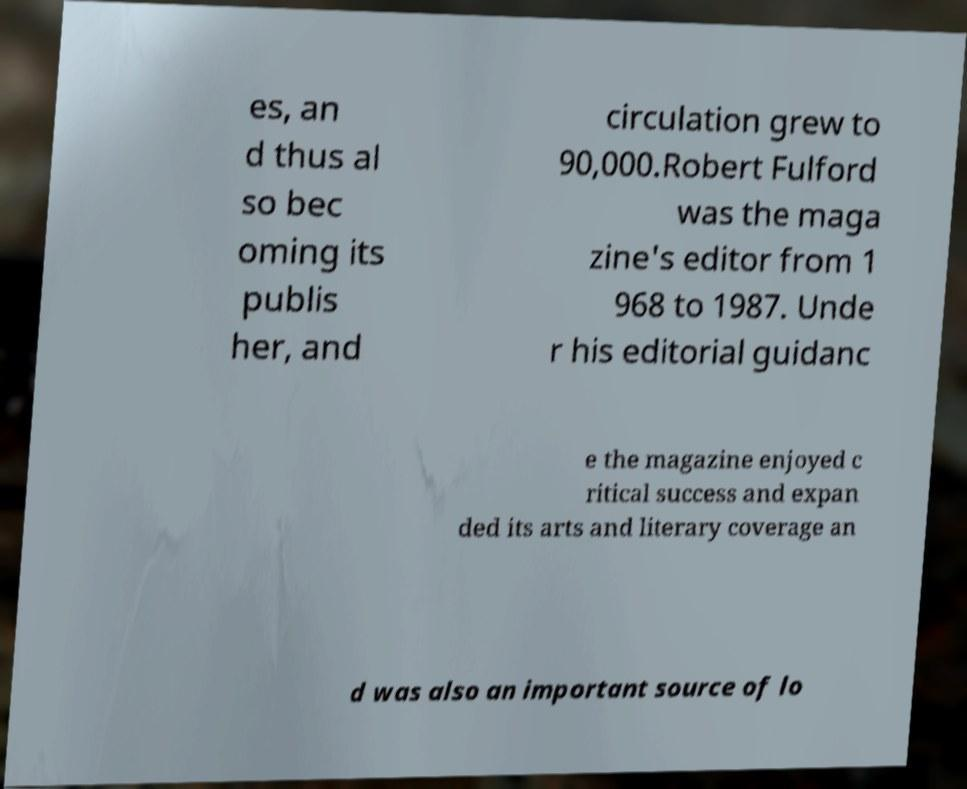Please identify and transcribe the text found in this image. es, an d thus al so bec oming its publis her, and circulation grew to 90,000.Robert Fulford was the maga zine's editor from 1 968 to 1987. Unde r his editorial guidanc e the magazine enjoyed c ritical success and expan ded its arts and literary coverage an d was also an important source of lo 